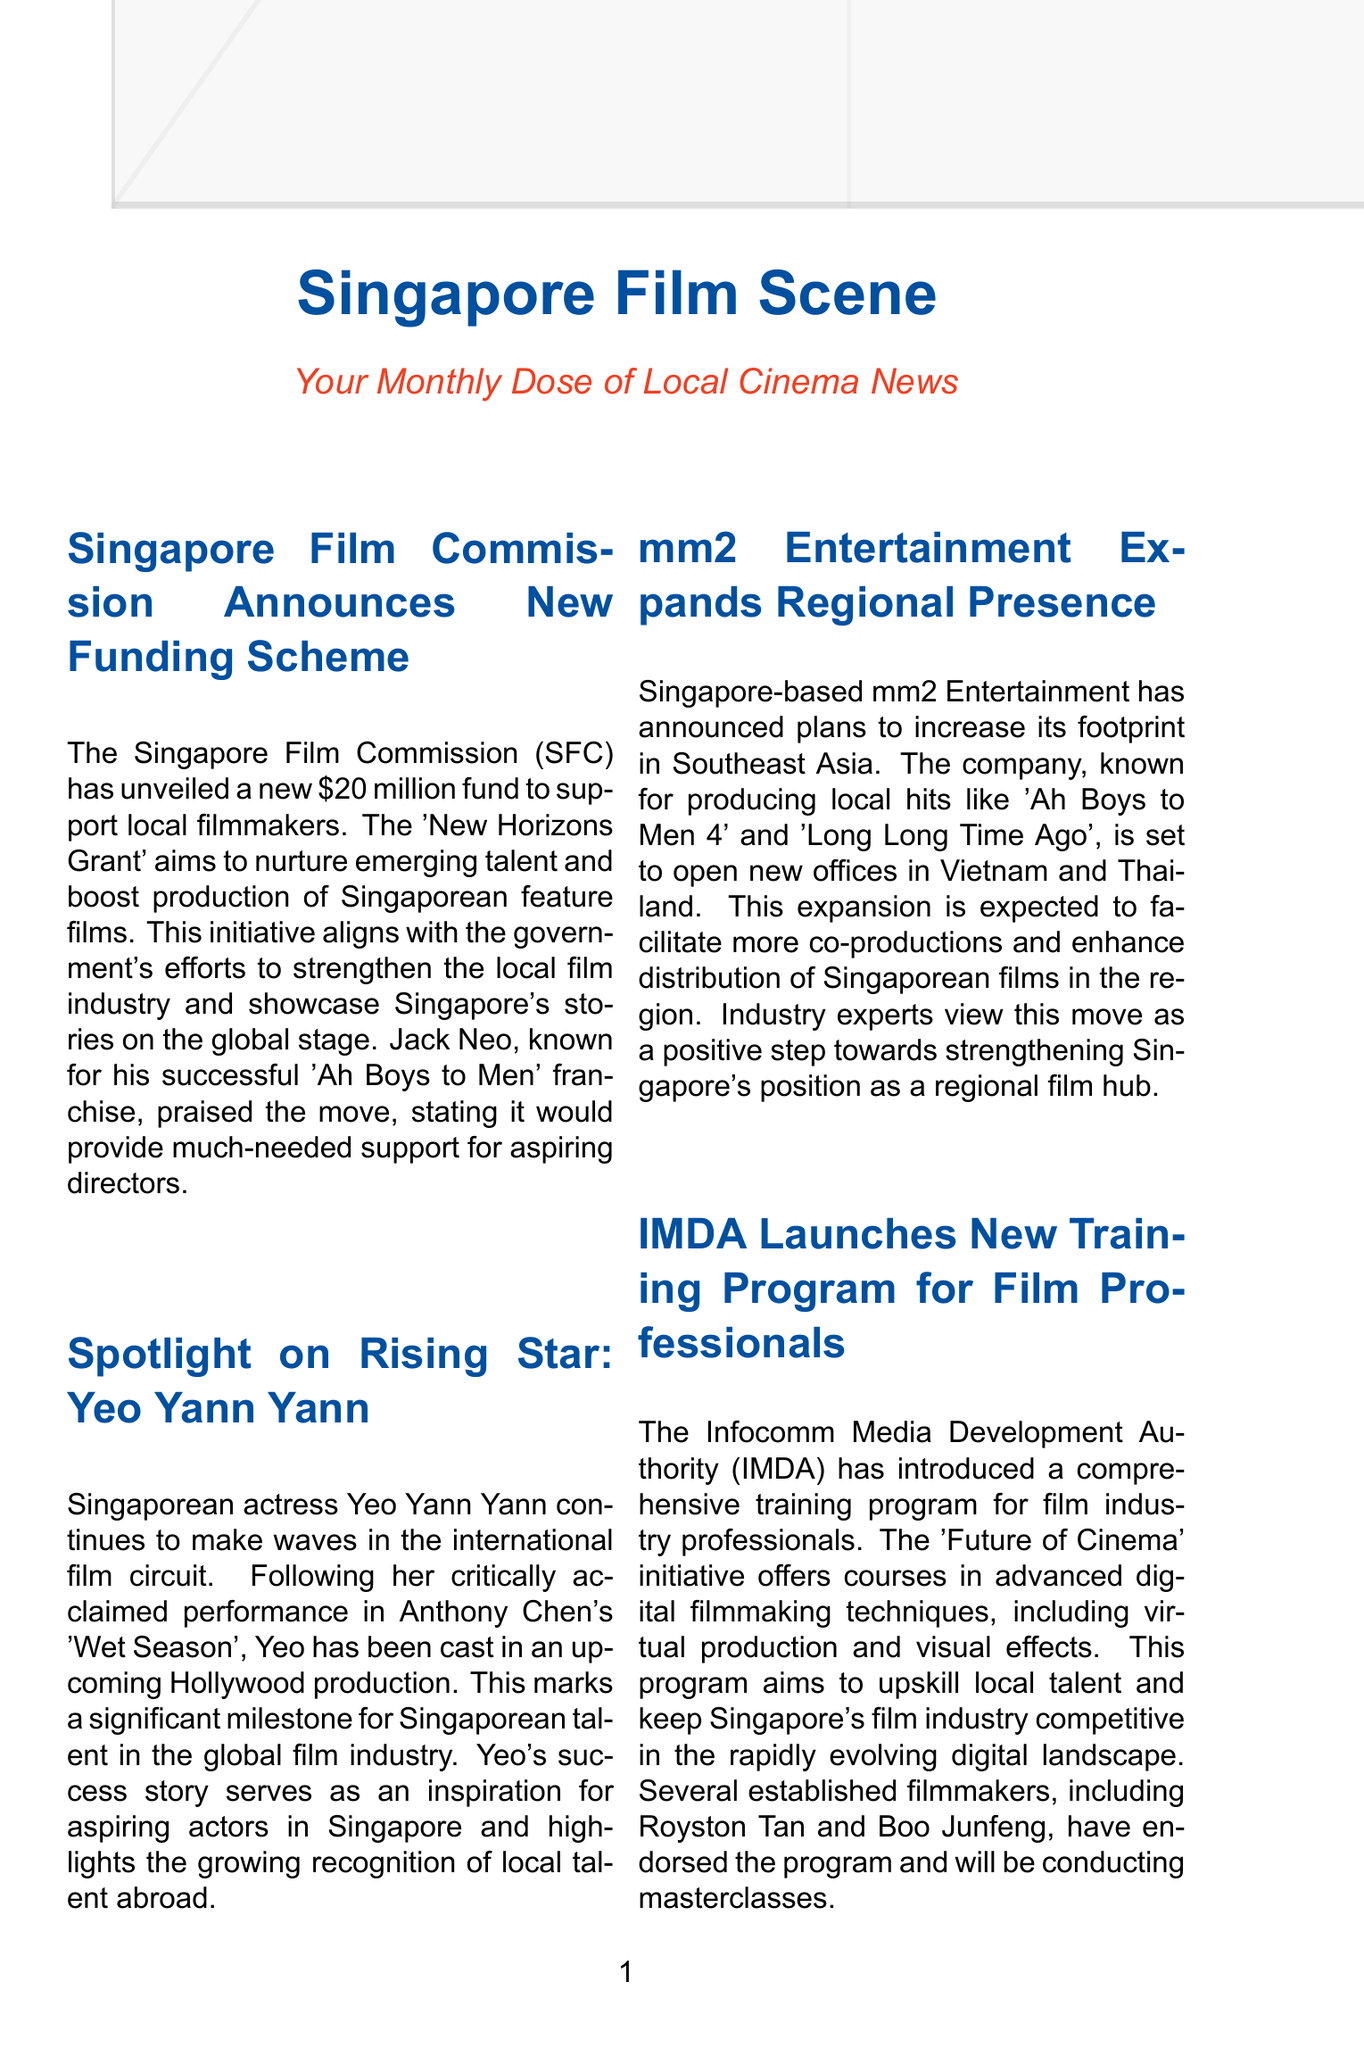What is the name of the new funding scheme announced by the Singapore Film Commission? The new funding scheme announced by the Singapore Film Commission is called the 'New Horizons Grant'.
Answer: 'New Horizons Grant' How much is the funding amount for the new scheme? The funding amount for the new scheme is $20 million.
Answer: $20 million Who is the rising star spotlighted in the newsletter? The rising star spotlighted in the newsletter is Yeo Yann Yann.
Answer: Yeo Yann Yann Which film did Yeo Yann Yann receive acclaim for? Yeo Yann Yann received acclaim for her performance in Anthony Chen's 'Wet Season'.
Answer: 'Wet Season' What is the new category announced by the Singapore International Film Festival? The new category announced by the Singapore International Film Festival is 'Southeast Asian Shorts'.
Answer: 'Southeast Asian Shorts' What is the primary aim of the IMDA's new training program? The primary aim of the IMDA's new training program is to upskill local talent.
Answer: upskill local talent Which company is expanding its presence in Southeast Asia? The company expanding its presence in Southeast Asia is mm2 Entertainment.
Answer: mm2 Entertainment What initiative aligns with the government's efforts to boost the local film industry? The initiative that aligns with the government's efforts to boost the local film industry is the 'New Horizons Grant'.
Answer: 'New Horizons Grant' 